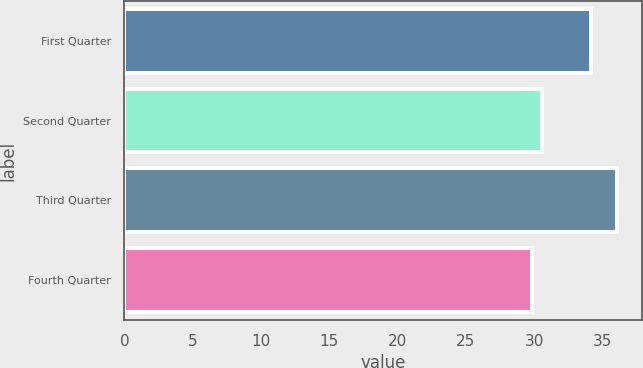Convert chart. <chart><loc_0><loc_0><loc_500><loc_500><bar_chart><fcel>First Quarter<fcel>Second Quarter<fcel>Third Quarter<fcel>Fourth Quarter<nl><fcel>34.13<fcel>30.6<fcel>36.09<fcel>29.83<nl></chart> 